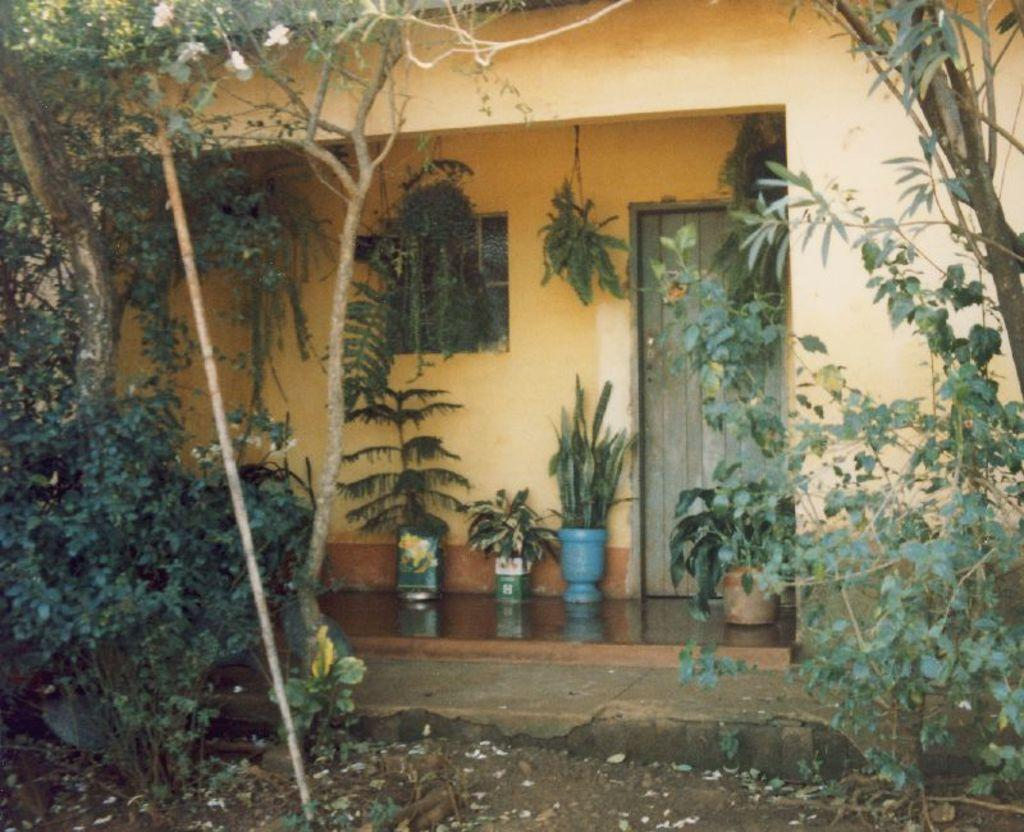What type of structure is visible in the image? There is a building in the image. What can be seen on the right side of the image? There are trees on the right side of the image. What can be seen on the left side of the image? There are trees on the left side of the image. What is located in the middle of the image? There are plants in the middle of the image. What is present at the bottom of the image? There are leaves at the bottom of the image. What color is the ink on the sofa in the image? There is no sofa or ink present in the image. 